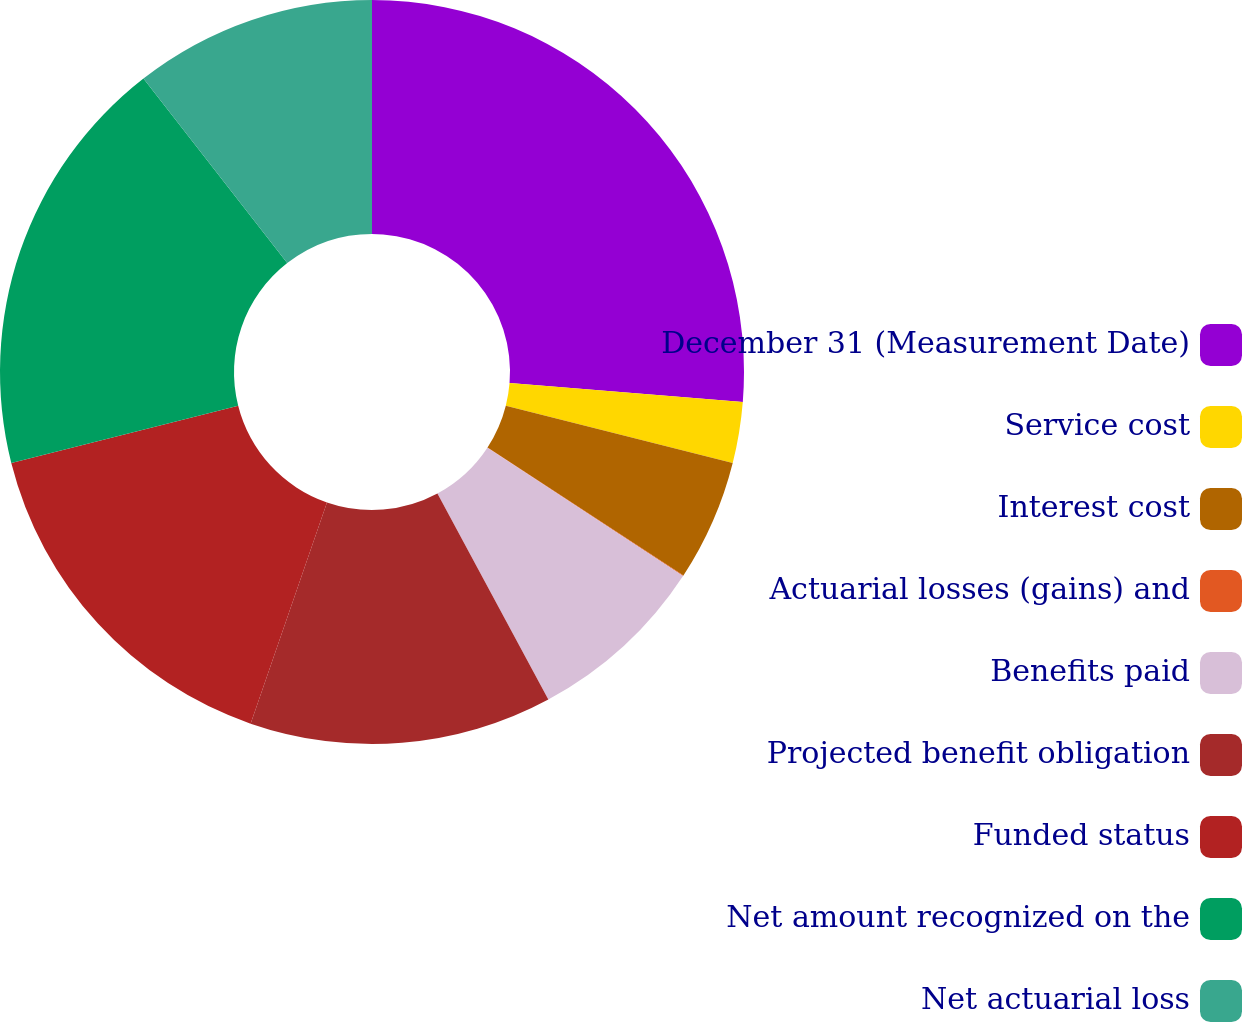<chart> <loc_0><loc_0><loc_500><loc_500><pie_chart><fcel>December 31 (Measurement Date)<fcel>Service cost<fcel>Interest cost<fcel>Actuarial losses (gains) and<fcel>Benefits paid<fcel>Projected benefit obligation<fcel>Funded status<fcel>Net amount recognized on the<fcel>Net actuarial loss<nl><fcel>26.28%<fcel>2.65%<fcel>5.28%<fcel>0.03%<fcel>7.9%<fcel>13.15%<fcel>15.78%<fcel>18.4%<fcel>10.53%<nl></chart> 